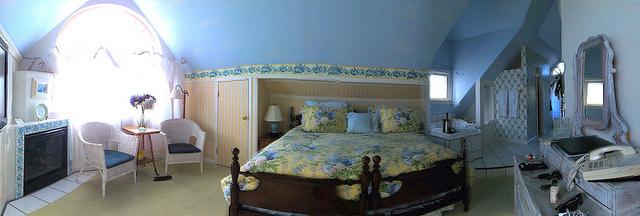Why is there a dog head in top left corner?
Concise answer only. Party. What is on top of the vanity?
Keep it brief. Phone. How many beds are in this room?
Write a very short answer. 1. 